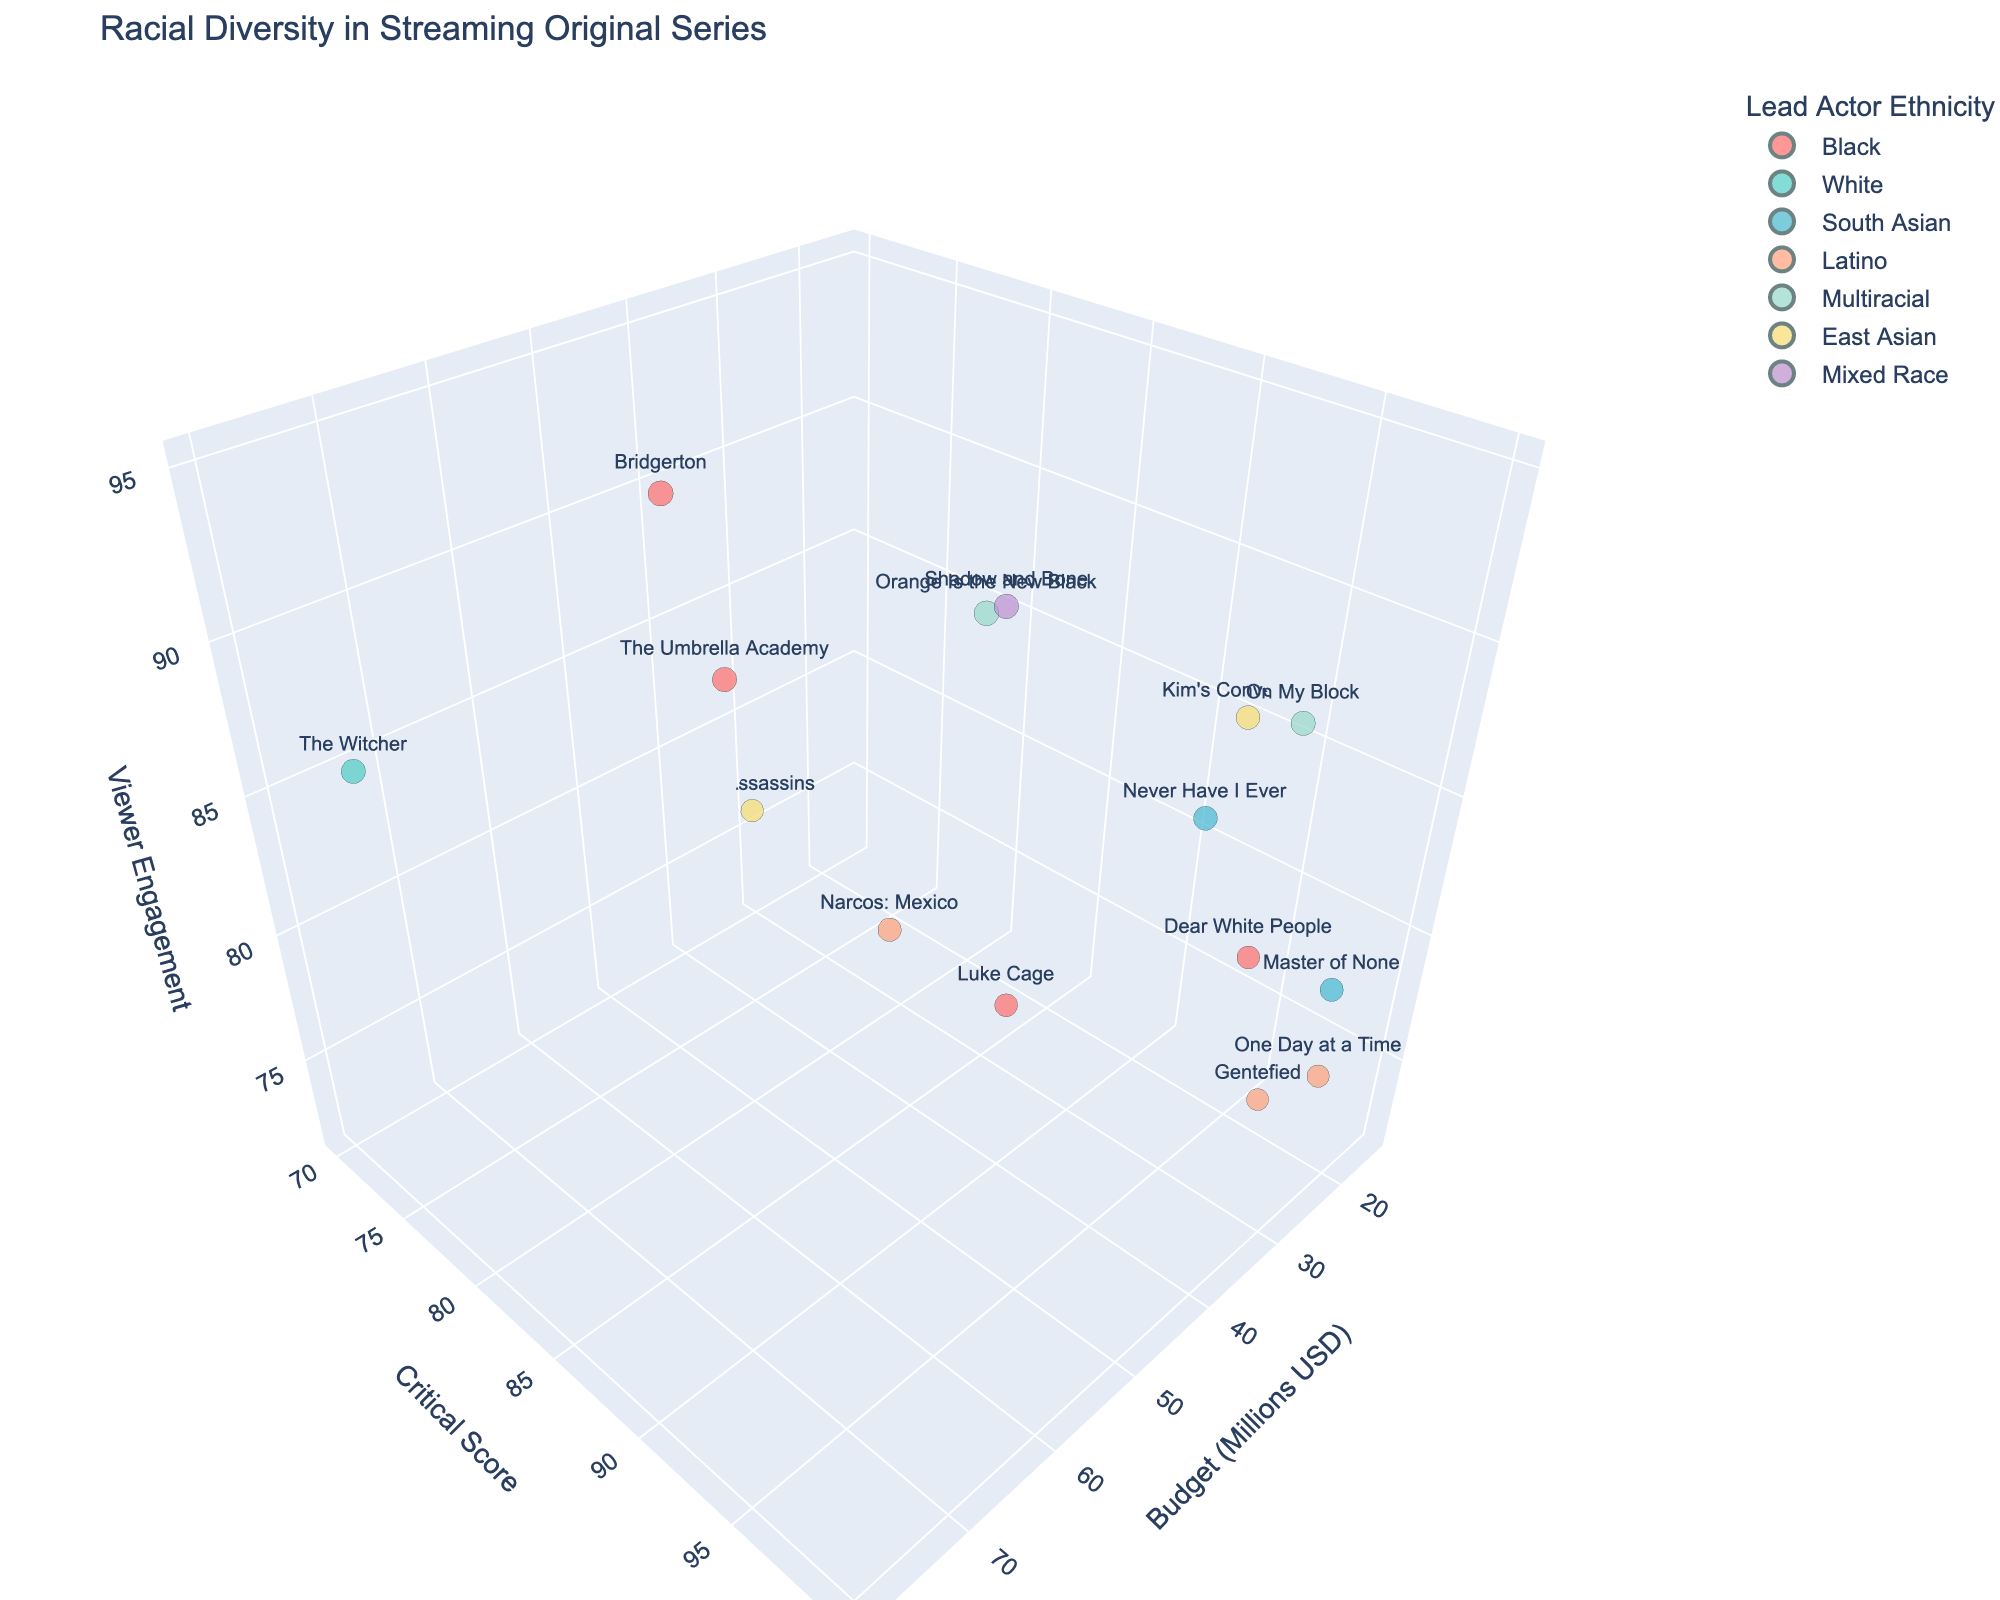What is the title of the 3D bubble chart? Look at the top of the chart, the title is usually displayed there.
Answer: Racial Diversity in Streaming Original Series How many data points are represented in the chart? Count the number of bubbles in the chart.
Answer: 15 What is the range of budgets (in millions USD) displayed on the x-axis? Look at the lowest and highest values on the x-axis of the chart.
Answer: 15 to 80 million USD Which series has the highest critical score? Identify the bubble at the maximum value on the y-axis (Critical Score).
Answer: Master of None What series has the highest viewer engagement? Identify the bubble at the maximum value on the z-axis (Viewer Engagement).
Answer: Bridgerton Which ethnicity appears most frequently as the lead actor in the series? Count the number of bubbles for each color representing different ethnicities and identify the most frequent.
Answer: Black How does the viewer engagement of 'The Witcher' compare to 'Master of None'? Locate both series and compare their positions on the z-axis (Viewer Engagement).
Answer: The Witcher has 88, while Master of None has 80; The Witcher is higher What is the average budget for series led by South Asian actors? Identify the bubbles for South Asian ethnicity, note down their budget values, and calculate the average.
Answer: (30 + 25) / 2 = 27.5 million USD Are there any series with a low budget but high critical score and viewer engagement? Find bubbles with low x-values (Budget), and high y-values (Critical Score) and z-values (Viewer Engagement).
Answer: Kim's Convenience and One Day at a Time Which series has the highest combination of critical score and viewer engagement? Add the y-values (Critical Score) and z-values (Viewer Engagement) for each bubble and identify the highest sum.
Answer: Bridgerton with 82 + 95 = 177 